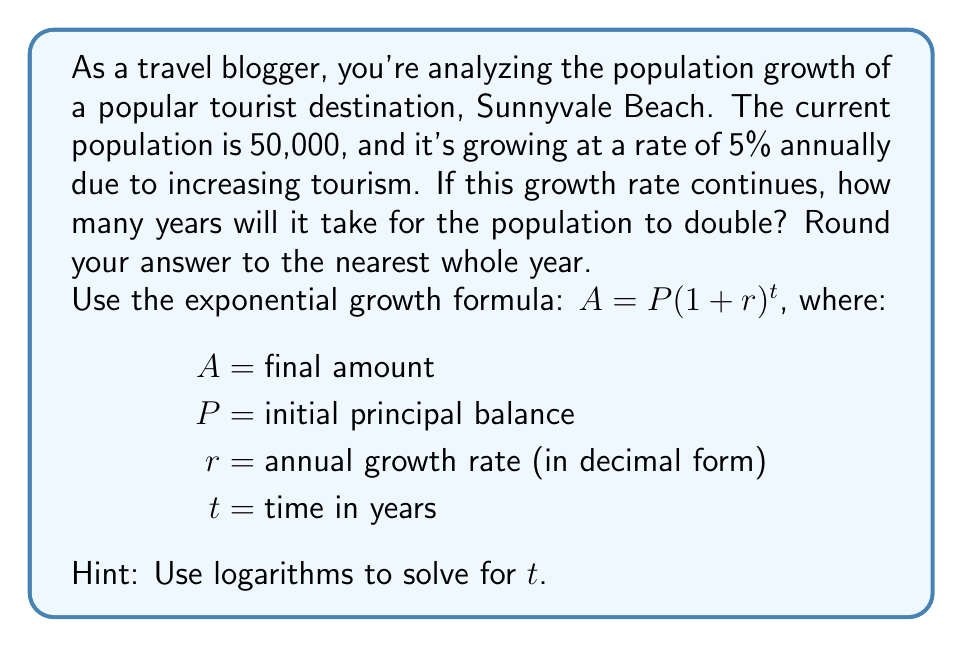Can you solve this math problem? Let's approach this step-by-step:

1) We want to find when the population doubles, so we can set up the equation:

   $100,000 = 50,000(1 + 0.05)^t$

2) Simplify the right side:

   $100,000 = 50,000(1.05)^t$

3) Divide both sides by 50,000:

   $2 = (1.05)^t$

4) Now, we can use logarithms to solve for $t$. Let's use the natural log (ln) on both sides:

   $\ln(2) = \ln((1.05)^t)$

5) Using the logarithm property $\ln(a^b) = b\ln(a)$, we get:

   $\ln(2) = t\ln(1.05)$

6) Now we can solve for $t$:

   $t = \frac{\ln(2)}{\ln(1.05)}$

7) Using a calculator:

   $t \approx 14.2067$

8) Rounding to the nearest whole year:

   $t = 14$ years
Answer: 14 years 